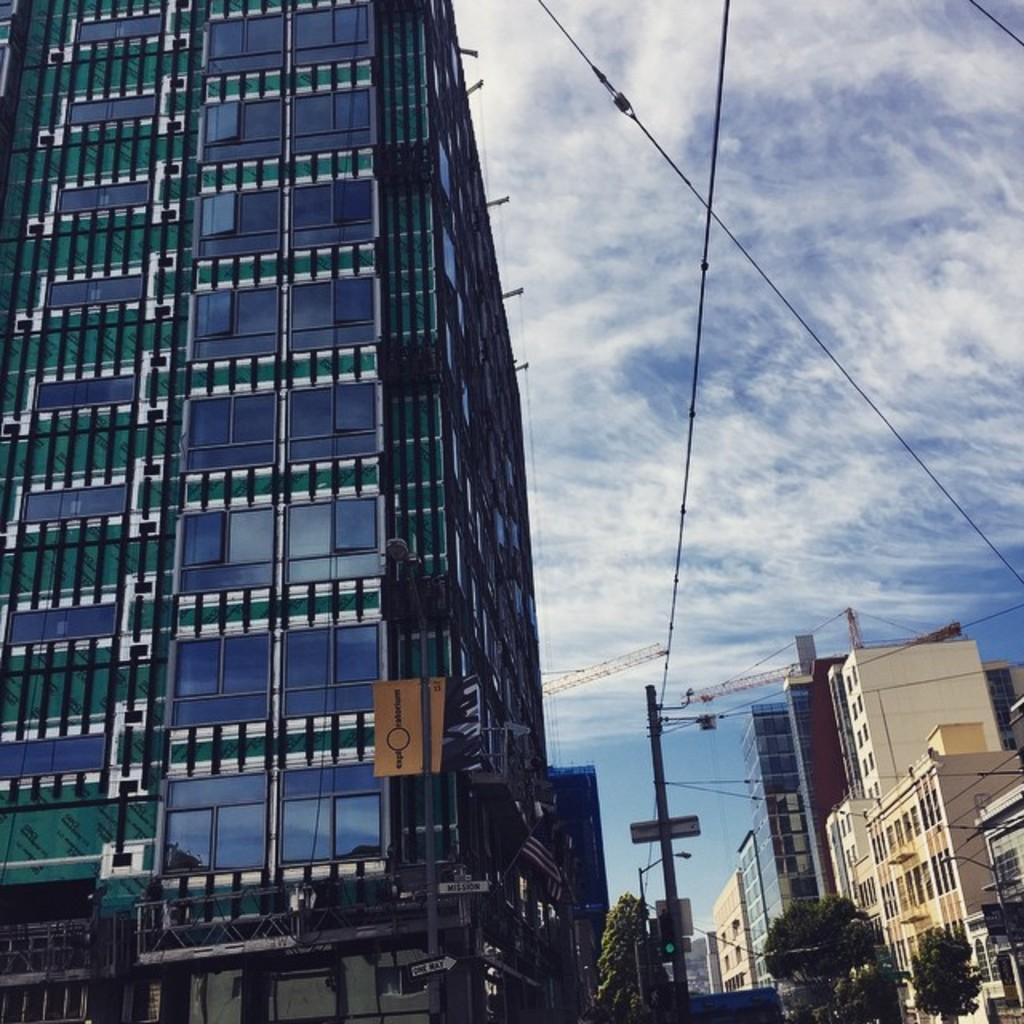What type of structure is visible in the image? There is a building in the image. What else can be seen in the image besides the building? There are electrical poles in the image. How are the building and electrical poles positioned in relation to each other? The building is in front of the electrical poles. How much pain do the boys feel in the image? There are no boys present in the image, so it is not possible to determine if they feel any pain. 